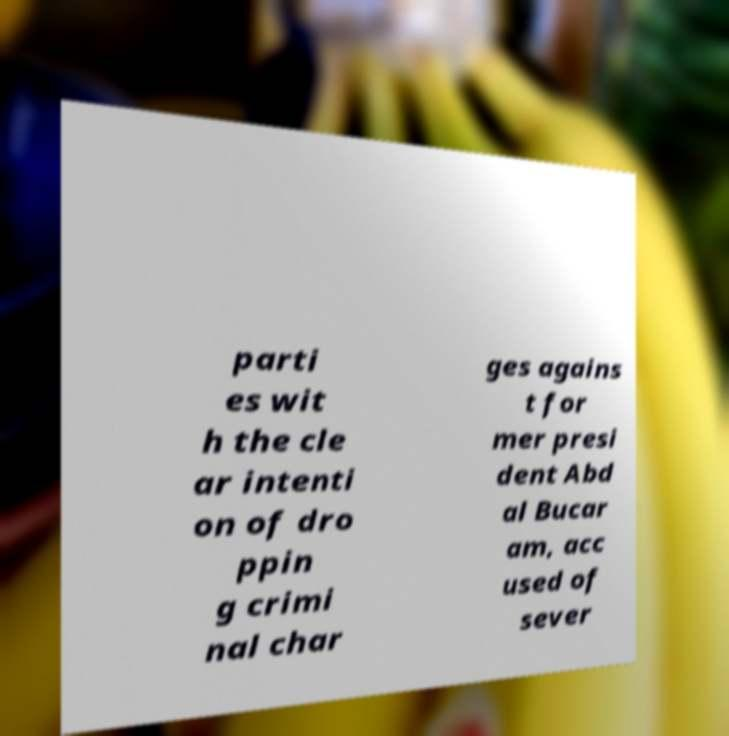Could you assist in decoding the text presented in this image and type it out clearly? parti es wit h the cle ar intenti on of dro ppin g crimi nal char ges agains t for mer presi dent Abd al Bucar am, acc used of sever 